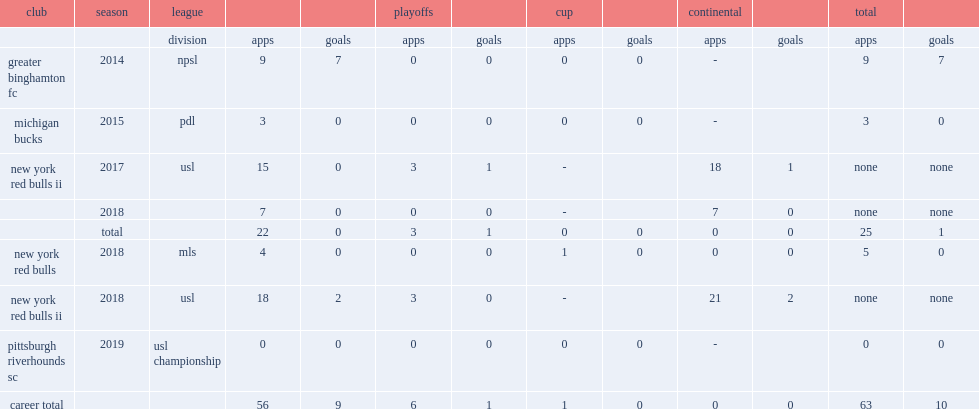Which club did kutler play for in 2019? Pittsburgh riverhounds sc. 